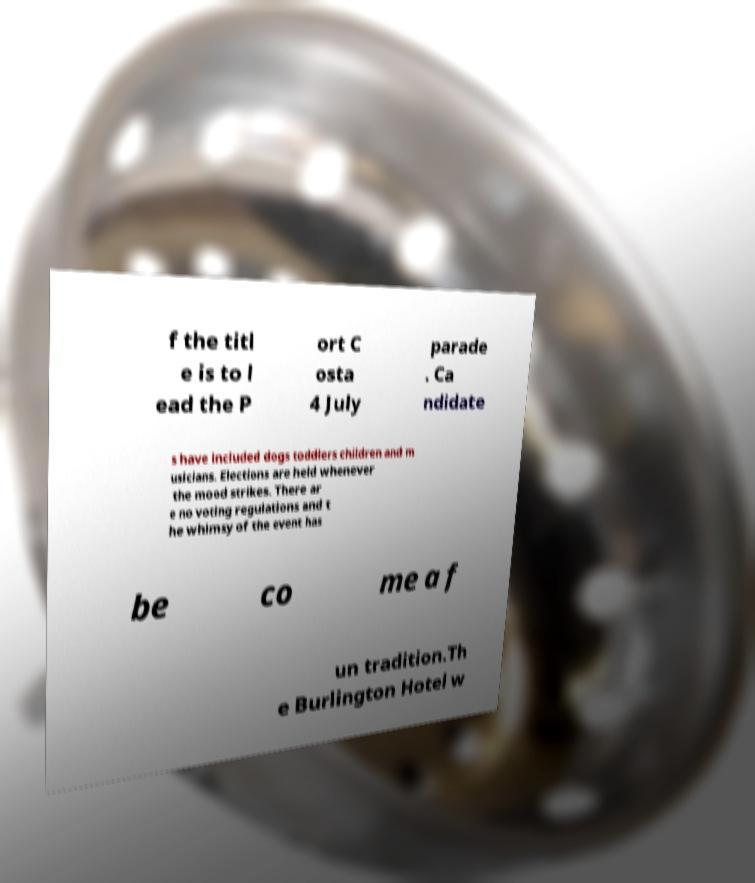Can you read and provide the text displayed in the image?This photo seems to have some interesting text. Can you extract and type it out for me? f the titl e is to l ead the P ort C osta 4 July parade . Ca ndidate s have included dogs toddlers children and m usicians. Elections are held whenever the mood strikes. There ar e no voting regulations and t he whimsy of the event has be co me a f un tradition.Th e Burlington Hotel w 